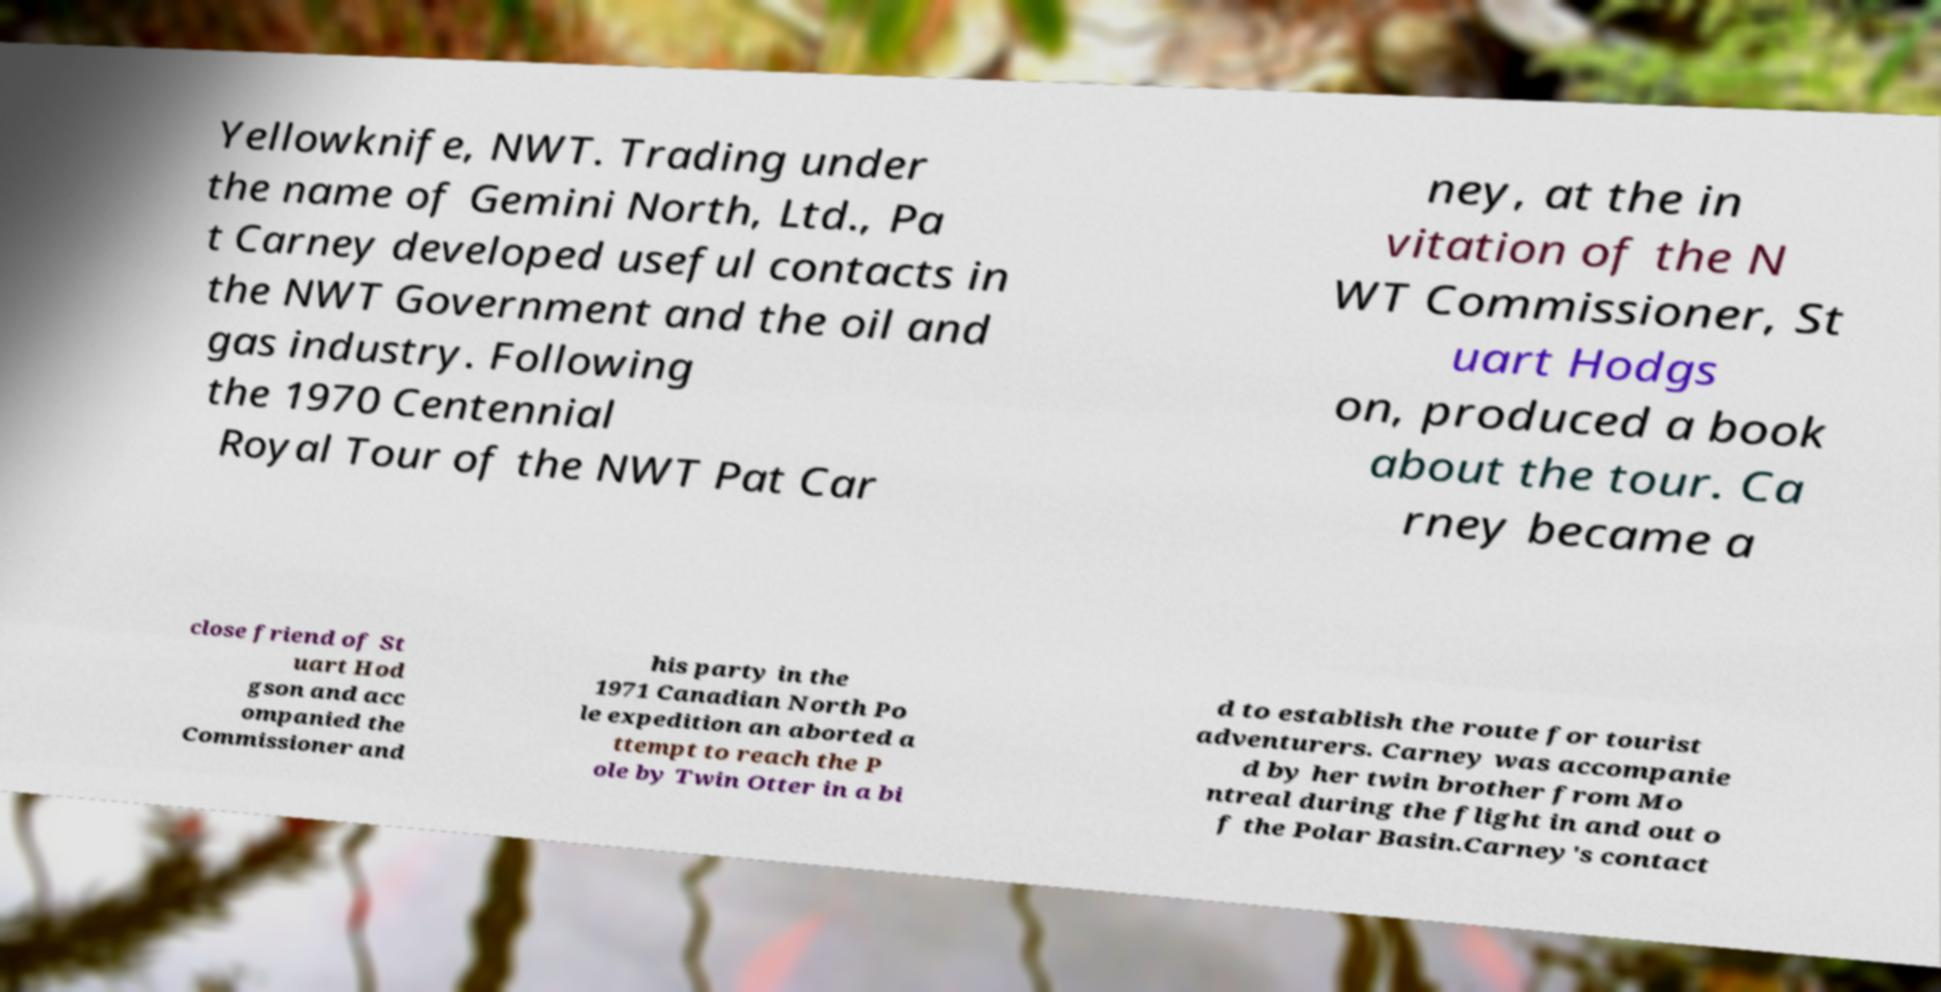There's text embedded in this image that I need extracted. Can you transcribe it verbatim? Yellowknife, NWT. Trading under the name of Gemini North, Ltd., Pa t Carney developed useful contacts in the NWT Government and the oil and gas industry. Following the 1970 Centennial Royal Tour of the NWT Pat Car ney, at the in vitation of the N WT Commissioner, St uart Hodgs on, produced a book about the tour. Ca rney became a close friend of St uart Hod gson and acc ompanied the Commissioner and his party in the 1971 Canadian North Po le expedition an aborted a ttempt to reach the P ole by Twin Otter in a bi d to establish the route for tourist adventurers. Carney was accompanie d by her twin brother from Mo ntreal during the flight in and out o f the Polar Basin.Carney's contact 